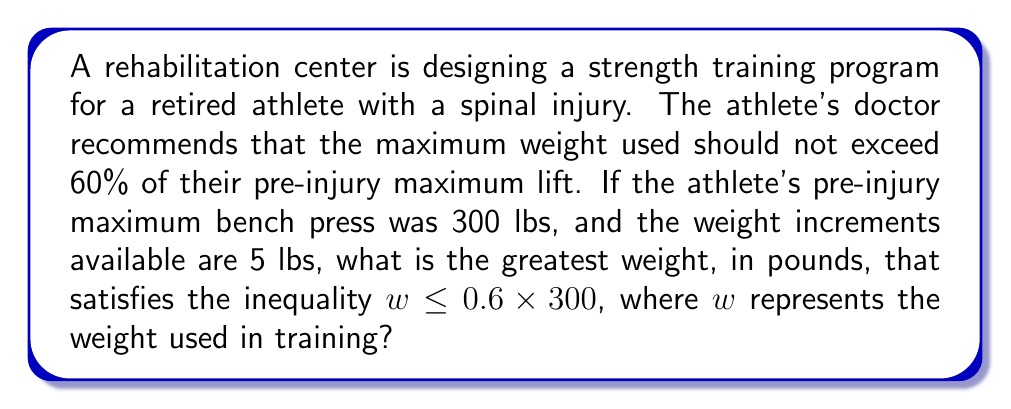Help me with this question. 1) First, let's set up the inequality:
   $w \leq 0.6 \times 300$

2) Simplify the right side of the inequality:
   $w \leq 180$

3) This means the maximum weight should not exceed 180 lbs.

4) However, we need to consider that the weight increments available are 5 lbs.

5) To find the greatest weight that satisfies the inequality and is divisible by 5, we need to find the largest multiple of 5 that is less than or equal to 180.

6) We can do this by dividing 180 by 5 and rounding down to the nearest whole number:
   $\lfloor \frac{180}{5} \rfloor = 36$

7) Then multiply this result by 5:
   $36 \times 5 = 180$

Therefore, the greatest weight that satisfies the inequality and is available in the given increments is 180 lbs.
Answer: 180 lbs 